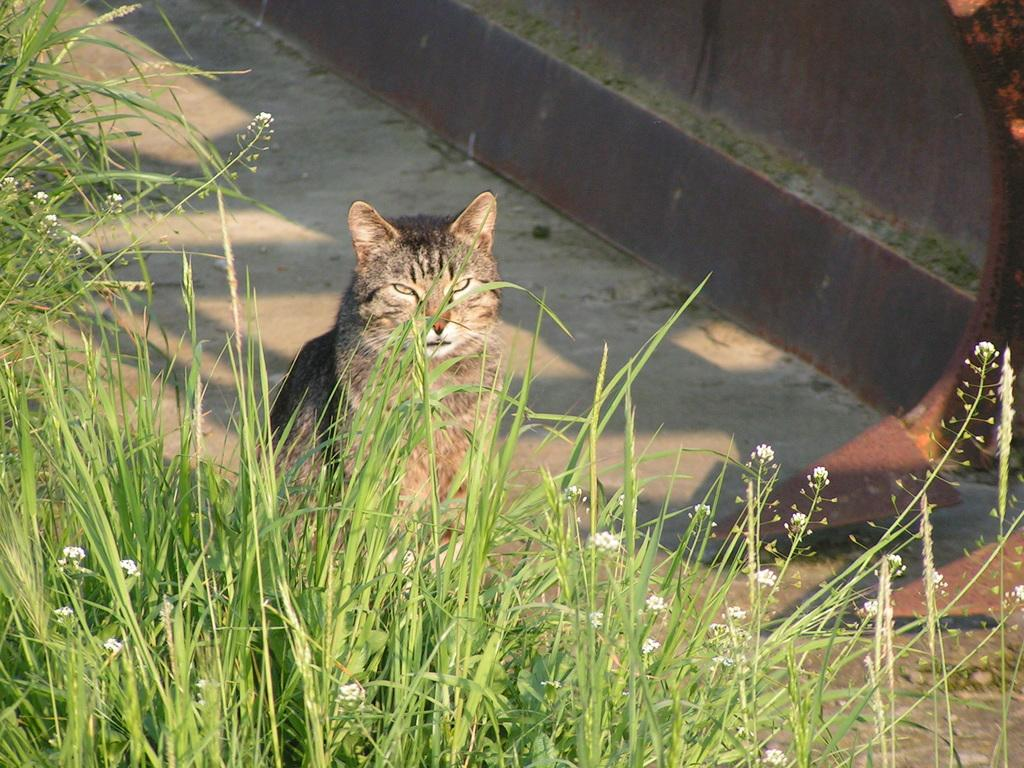What animal can be seen on the ground in the image? There is a cat on the ground in the image. What type of vegetation is present in the image? There are plants with flowers in the image. What structure is visible in the image? There is a wall visible in the image. What type of car is parked behind the wall in the image? There is no car present in the image; only a cat, plants with flowers, and a wall are visible. 